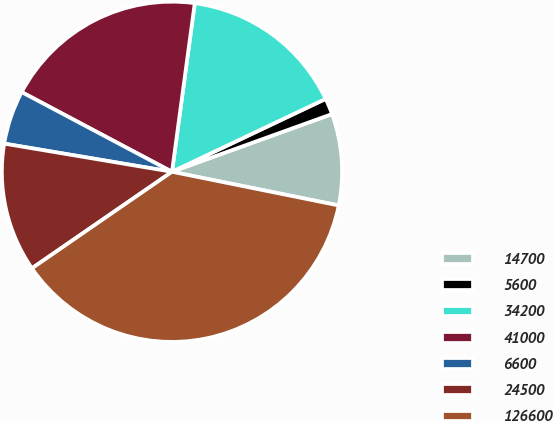Convert chart to OTSL. <chart><loc_0><loc_0><loc_500><loc_500><pie_chart><fcel>14700<fcel>5600<fcel>34200<fcel>41000<fcel>6600<fcel>24500<fcel>126600<nl><fcel>8.68%<fcel>1.54%<fcel>15.81%<fcel>19.38%<fcel>5.11%<fcel>12.25%<fcel>37.22%<nl></chart> 